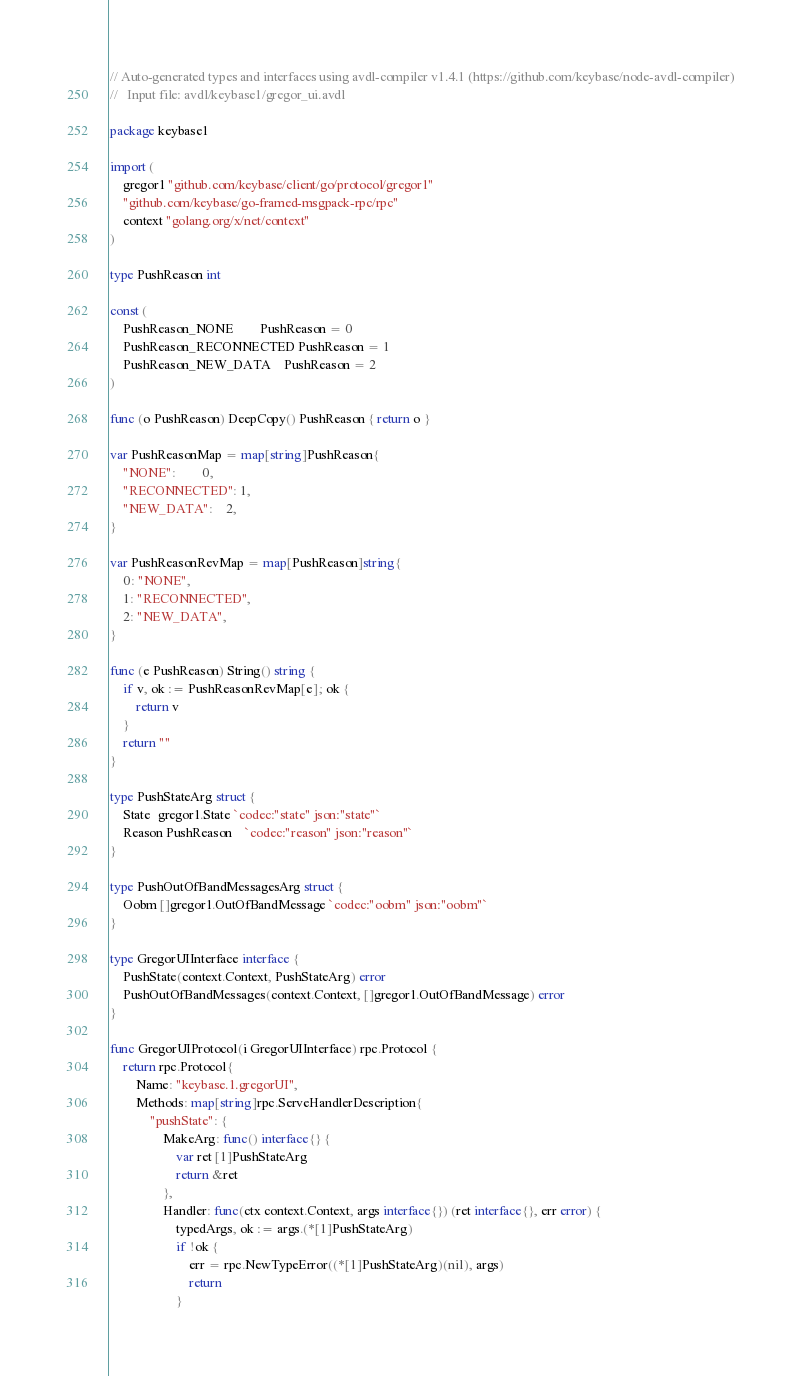<code> <loc_0><loc_0><loc_500><loc_500><_Go_>// Auto-generated types and interfaces using avdl-compiler v1.4.1 (https://github.com/keybase/node-avdl-compiler)
//   Input file: avdl/keybase1/gregor_ui.avdl

package keybase1

import (
	gregor1 "github.com/keybase/client/go/protocol/gregor1"
	"github.com/keybase/go-framed-msgpack-rpc/rpc"
	context "golang.org/x/net/context"
)

type PushReason int

const (
	PushReason_NONE        PushReason = 0
	PushReason_RECONNECTED PushReason = 1
	PushReason_NEW_DATA    PushReason = 2
)

func (o PushReason) DeepCopy() PushReason { return o }

var PushReasonMap = map[string]PushReason{
	"NONE":        0,
	"RECONNECTED": 1,
	"NEW_DATA":    2,
}

var PushReasonRevMap = map[PushReason]string{
	0: "NONE",
	1: "RECONNECTED",
	2: "NEW_DATA",
}

func (e PushReason) String() string {
	if v, ok := PushReasonRevMap[e]; ok {
		return v
	}
	return ""
}

type PushStateArg struct {
	State  gregor1.State `codec:"state" json:"state"`
	Reason PushReason    `codec:"reason" json:"reason"`
}

type PushOutOfBandMessagesArg struct {
	Oobm []gregor1.OutOfBandMessage `codec:"oobm" json:"oobm"`
}

type GregorUIInterface interface {
	PushState(context.Context, PushStateArg) error
	PushOutOfBandMessages(context.Context, []gregor1.OutOfBandMessage) error
}

func GregorUIProtocol(i GregorUIInterface) rpc.Protocol {
	return rpc.Protocol{
		Name: "keybase.1.gregorUI",
		Methods: map[string]rpc.ServeHandlerDescription{
			"pushState": {
				MakeArg: func() interface{} {
					var ret [1]PushStateArg
					return &ret
				},
				Handler: func(ctx context.Context, args interface{}) (ret interface{}, err error) {
					typedArgs, ok := args.(*[1]PushStateArg)
					if !ok {
						err = rpc.NewTypeError((*[1]PushStateArg)(nil), args)
						return
					}</code> 